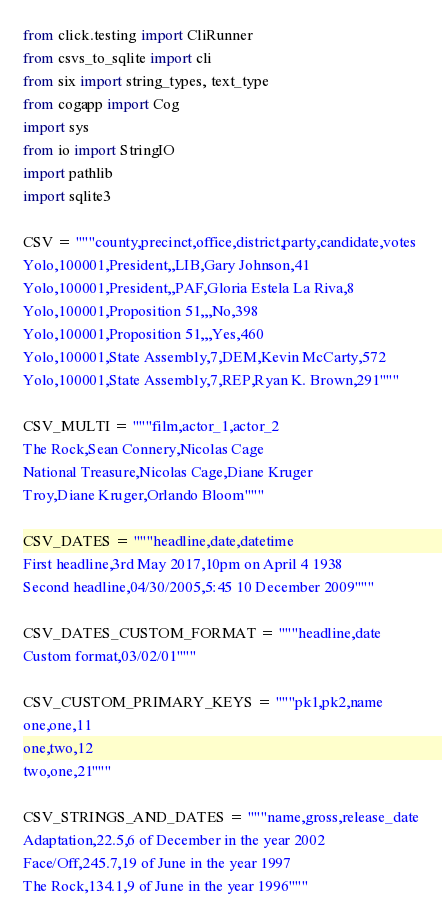Convert code to text. <code><loc_0><loc_0><loc_500><loc_500><_Python_>from click.testing import CliRunner
from csvs_to_sqlite import cli
from six import string_types, text_type
from cogapp import Cog
import sys
from io import StringIO
import pathlib
import sqlite3

CSV = """county,precinct,office,district,party,candidate,votes
Yolo,100001,President,,LIB,Gary Johnson,41
Yolo,100001,President,,PAF,Gloria Estela La Riva,8
Yolo,100001,Proposition 51,,,No,398
Yolo,100001,Proposition 51,,,Yes,460
Yolo,100001,State Assembly,7,DEM,Kevin McCarty,572
Yolo,100001,State Assembly,7,REP,Ryan K. Brown,291"""

CSV_MULTI = """film,actor_1,actor_2
The Rock,Sean Connery,Nicolas Cage
National Treasure,Nicolas Cage,Diane Kruger
Troy,Diane Kruger,Orlando Bloom"""

CSV_DATES = """headline,date,datetime
First headline,3rd May 2017,10pm on April 4 1938
Second headline,04/30/2005,5:45 10 December 2009"""

CSV_DATES_CUSTOM_FORMAT = """headline,date
Custom format,03/02/01"""

CSV_CUSTOM_PRIMARY_KEYS = """pk1,pk2,name
one,one,11
one,two,12
two,one,21"""

CSV_STRINGS_AND_DATES = """name,gross,release_date
Adaptation,22.5,6 of December in the year 2002
Face/Off,245.7,19 of June in the year 1997
The Rock,134.1,9 of June in the year 1996"""

</code> 